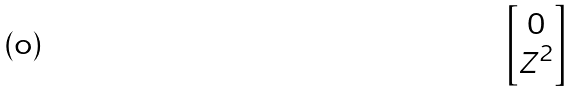Convert formula to latex. <formula><loc_0><loc_0><loc_500><loc_500>\begin{bmatrix} 0 \\ Z ^ { 2 } \end{bmatrix}</formula> 